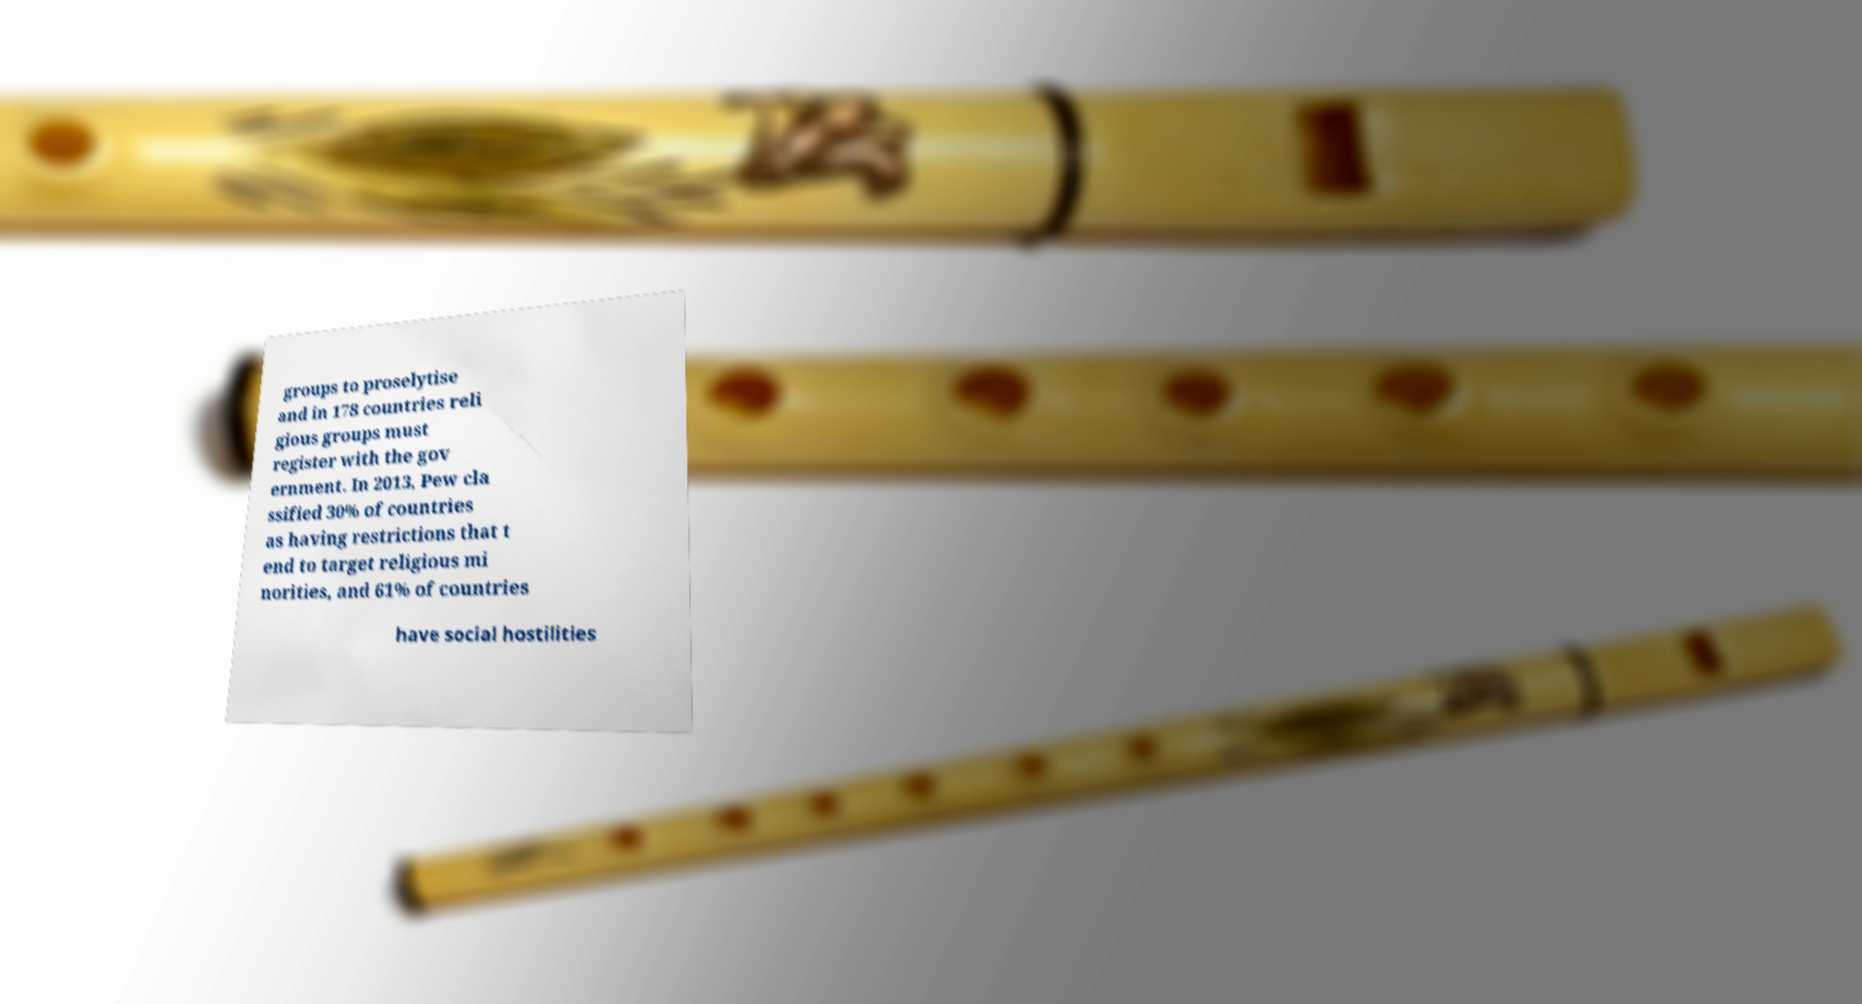Please identify and transcribe the text found in this image. groups to proselytise and in 178 countries reli gious groups must register with the gov ernment. In 2013, Pew cla ssified 30% of countries as having restrictions that t end to target religious mi norities, and 61% of countries have social hostilities 